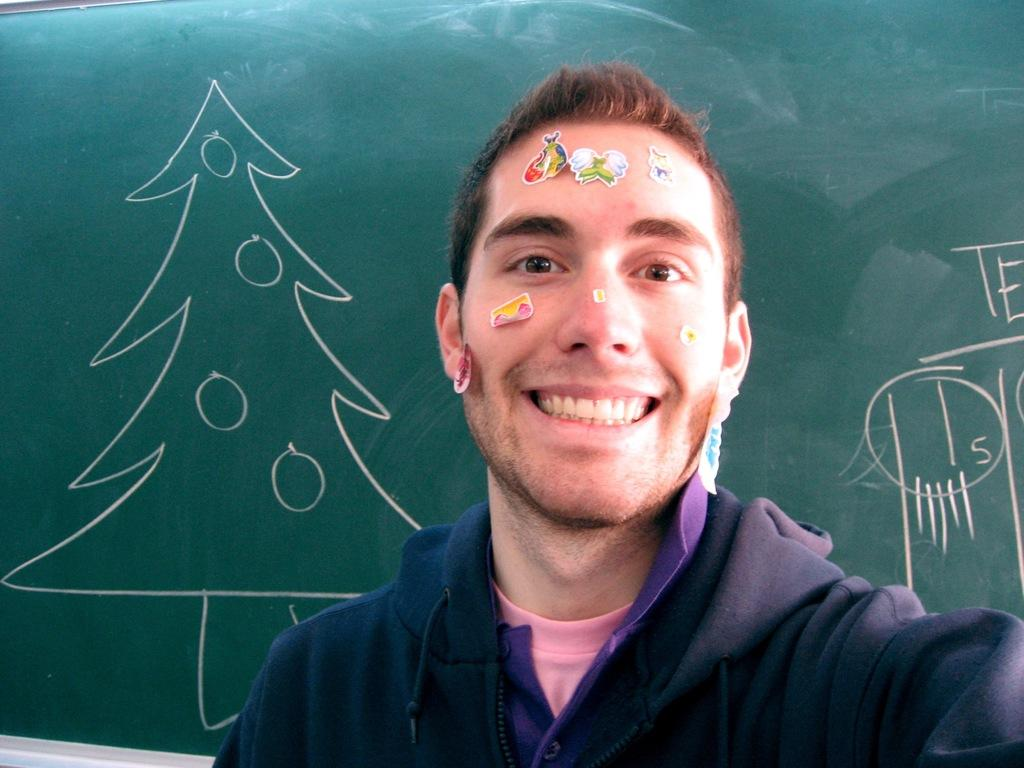Who is present in the image? There is a man in the image. What is the man wearing? The man is wearing a coat. What is on the man's face can be seen in the image? There are stickers on the man's face. What can be seen in the background of the image? There is a drawing and text on a board in the background of the image. What type of badge is the man wearing on his coat in the image? There is no badge visible on the man's coat in the image. How does the man react to the sleet falling in the image? There is no mention of sleet in the image, so it cannot be determined how the man would react to it. 